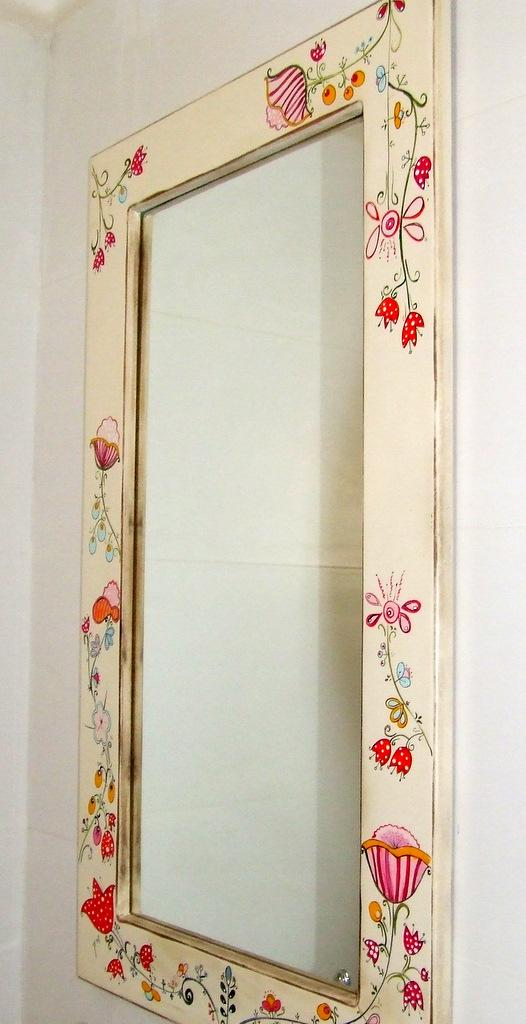What object is attached to the wall in the image? There is a mirror frame in the image, and it is attached to a wall. What colors can be seen on the mirror frame? The frame has cream, red, orange, and green colors. Did the mirror frame cause the earthquake in the image? There is no earthquake or any indication of an earthquake in the image. The mirror frame is simply attached to a wall with specific colors. 